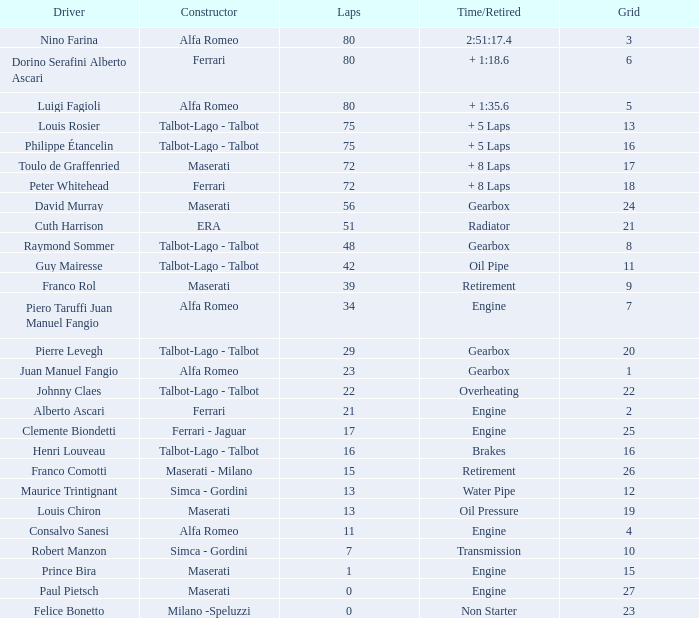When the grid is under 7, laps are over 17, and time/retired is + 1:3 Alfa Romeo. 